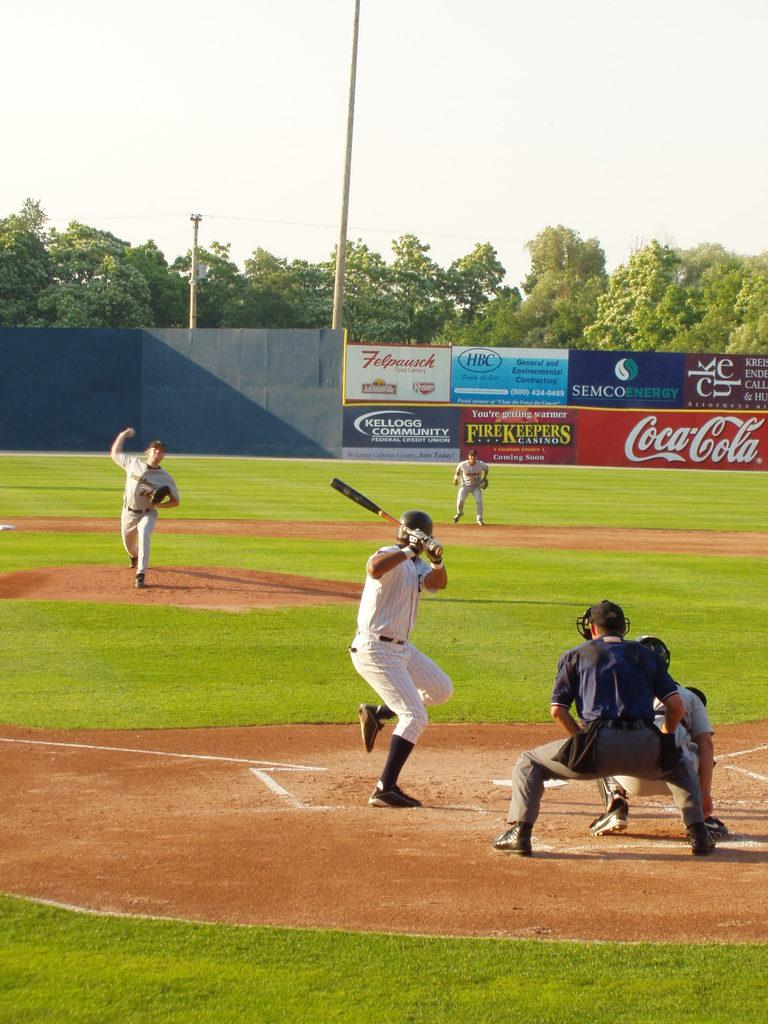<image>
Relay a brief, clear account of the picture shown. A baseball field with an ad for CocaCola in the background. 